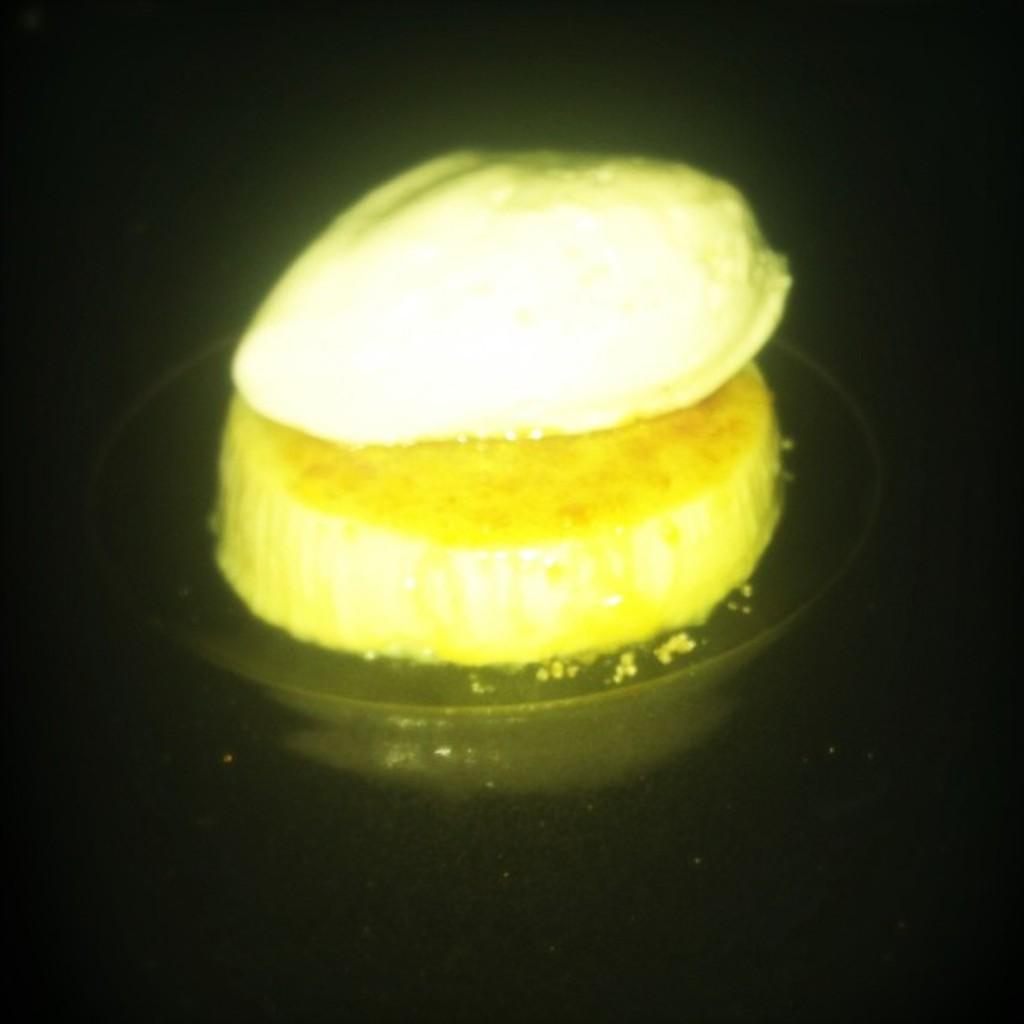What is in the center of the image? There is a plate in the center of the image. What is on the plate? There is a cake on the plate. What color is the background of the image? The background of the image is black. Can you see a snail crawling on the cake in the image? No, there is no snail present in the image. 